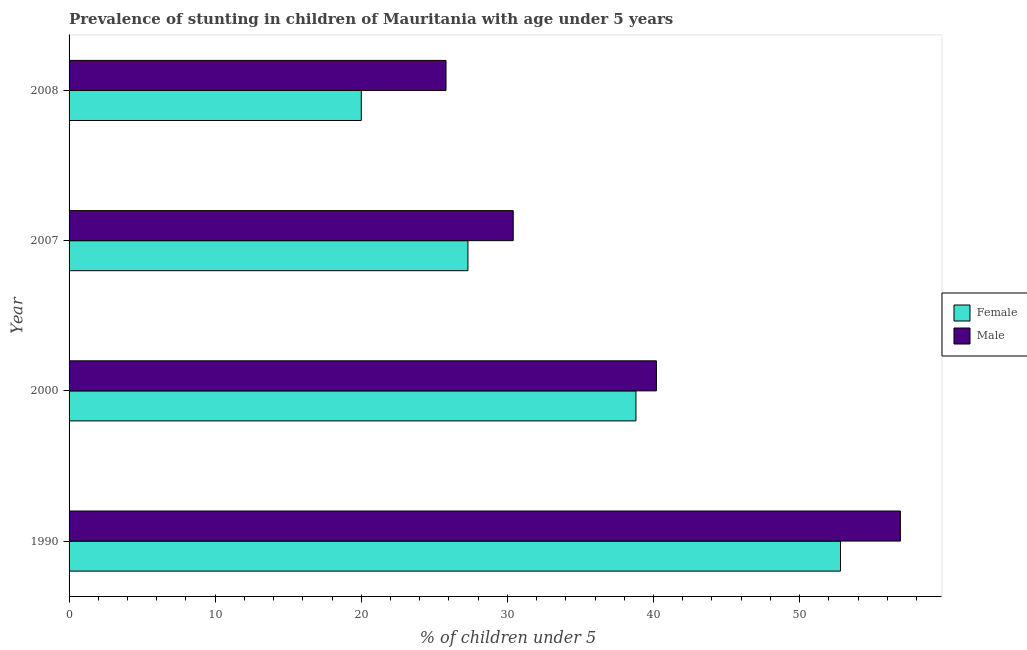How many different coloured bars are there?
Offer a very short reply. 2. How many groups of bars are there?
Keep it short and to the point. 4. Are the number of bars on each tick of the Y-axis equal?
Give a very brief answer. Yes. In how many cases, is the number of bars for a given year not equal to the number of legend labels?
Your answer should be compact. 0. What is the percentage of stunted female children in 1990?
Keep it short and to the point. 52.8. Across all years, what is the maximum percentage of stunted male children?
Make the answer very short. 56.9. What is the total percentage of stunted male children in the graph?
Your answer should be very brief. 153.3. What is the difference between the percentage of stunted male children in 2000 and that in 2008?
Keep it short and to the point. 14.4. What is the difference between the percentage of stunted female children in 1990 and the percentage of stunted male children in 2007?
Offer a very short reply. 22.4. What is the average percentage of stunted male children per year?
Your answer should be very brief. 38.33. What is the ratio of the percentage of stunted male children in 1990 to that in 2007?
Give a very brief answer. 1.87. Is the percentage of stunted male children in 1990 less than that in 2000?
Ensure brevity in your answer.  No. Is the difference between the percentage of stunted female children in 1990 and 2008 greater than the difference between the percentage of stunted male children in 1990 and 2008?
Keep it short and to the point. Yes. What is the difference between the highest and the second highest percentage of stunted female children?
Offer a terse response. 14. What is the difference between the highest and the lowest percentage of stunted female children?
Provide a succinct answer. 32.8. In how many years, is the percentage of stunted female children greater than the average percentage of stunted female children taken over all years?
Make the answer very short. 2. How many bars are there?
Give a very brief answer. 8. How many years are there in the graph?
Your answer should be compact. 4. What is the difference between two consecutive major ticks on the X-axis?
Keep it short and to the point. 10. Does the graph contain any zero values?
Make the answer very short. No. Does the graph contain grids?
Keep it short and to the point. No. Where does the legend appear in the graph?
Offer a terse response. Center right. How many legend labels are there?
Ensure brevity in your answer.  2. How are the legend labels stacked?
Ensure brevity in your answer.  Vertical. What is the title of the graph?
Ensure brevity in your answer.  Prevalence of stunting in children of Mauritania with age under 5 years. What is the label or title of the X-axis?
Ensure brevity in your answer.   % of children under 5. What is the  % of children under 5 of Female in 1990?
Keep it short and to the point. 52.8. What is the  % of children under 5 in Male in 1990?
Offer a very short reply. 56.9. What is the  % of children under 5 in Female in 2000?
Your answer should be compact. 38.8. What is the  % of children under 5 in Male in 2000?
Offer a very short reply. 40.2. What is the  % of children under 5 in Female in 2007?
Ensure brevity in your answer.  27.3. What is the  % of children under 5 of Male in 2007?
Provide a short and direct response. 30.4. What is the  % of children under 5 in Male in 2008?
Your answer should be compact. 25.8. Across all years, what is the maximum  % of children under 5 in Female?
Make the answer very short. 52.8. Across all years, what is the maximum  % of children under 5 in Male?
Ensure brevity in your answer.  56.9. Across all years, what is the minimum  % of children under 5 in Male?
Offer a very short reply. 25.8. What is the total  % of children under 5 of Female in the graph?
Your answer should be very brief. 138.9. What is the total  % of children under 5 in Male in the graph?
Your response must be concise. 153.3. What is the difference between the  % of children under 5 in Male in 1990 and that in 2000?
Keep it short and to the point. 16.7. What is the difference between the  % of children under 5 in Male in 1990 and that in 2007?
Keep it short and to the point. 26.5. What is the difference between the  % of children under 5 in Female in 1990 and that in 2008?
Your answer should be compact. 32.8. What is the difference between the  % of children under 5 of Male in 1990 and that in 2008?
Give a very brief answer. 31.1. What is the difference between the  % of children under 5 in Female in 2000 and that in 2007?
Your response must be concise. 11.5. What is the difference between the  % of children under 5 in Female in 2000 and that in 2008?
Ensure brevity in your answer.  18.8. What is the difference between the  % of children under 5 of Male in 2000 and that in 2008?
Offer a terse response. 14.4. What is the difference between the  % of children under 5 of Female in 1990 and the  % of children under 5 of Male in 2000?
Give a very brief answer. 12.6. What is the difference between the  % of children under 5 in Female in 1990 and the  % of children under 5 in Male in 2007?
Provide a succinct answer. 22.4. What is the difference between the  % of children under 5 of Female in 1990 and the  % of children under 5 of Male in 2008?
Give a very brief answer. 27. What is the average  % of children under 5 in Female per year?
Offer a very short reply. 34.73. What is the average  % of children under 5 in Male per year?
Provide a short and direct response. 38.33. What is the ratio of the  % of children under 5 in Female in 1990 to that in 2000?
Your response must be concise. 1.36. What is the ratio of the  % of children under 5 in Male in 1990 to that in 2000?
Your response must be concise. 1.42. What is the ratio of the  % of children under 5 in Female in 1990 to that in 2007?
Your response must be concise. 1.93. What is the ratio of the  % of children under 5 in Male in 1990 to that in 2007?
Your answer should be compact. 1.87. What is the ratio of the  % of children under 5 in Female in 1990 to that in 2008?
Give a very brief answer. 2.64. What is the ratio of the  % of children under 5 of Male in 1990 to that in 2008?
Provide a succinct answer. 2.21. What is the ratio of the  % of children under 5 of Female in 2000 to that in 2007?
Your answer should be compact. 1.42. What is the ratio of the  % of children under 5 in Male in 2000 to that in 2007?
Provide a succinct answer. 1.32. What is the ratio of the  % of children under 5 of Female in 2000 to that in 2008?
Ensure brevity in your answer.  1.94. What is the ratio of the  % of children under 5 of Male in 2000 to that in 2008?
Your response must be concise. 1.56. What is the ratio of the  % of children under 5 of Female in 2007 to that in 2008?
Offer a terse response. 1.36. What is the ratio of the  % of children under 5 in Male in 2007 to that in 2008?
Offer a very short reply. 1.18. What is the difference between the highest and the second highest  % of children under 5 of Male?
Your response must be concise. 16.7. What is the difference between the highest and the lowest  % of children under 5 of Female?
Offer a very short reply. 32.8. What is the difference between the highest and the lowest  % of children under 5 in Male?
Offer a terse response. 31.1. 